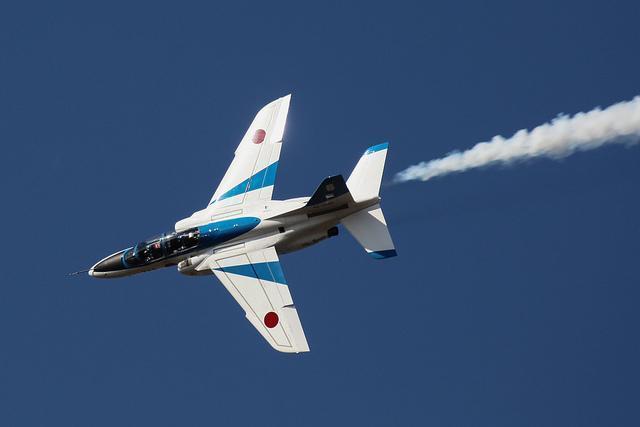How many people are in the train?
Give a very brief answer. 0. How many horses are shown?
Give a very brief answer. 0. 